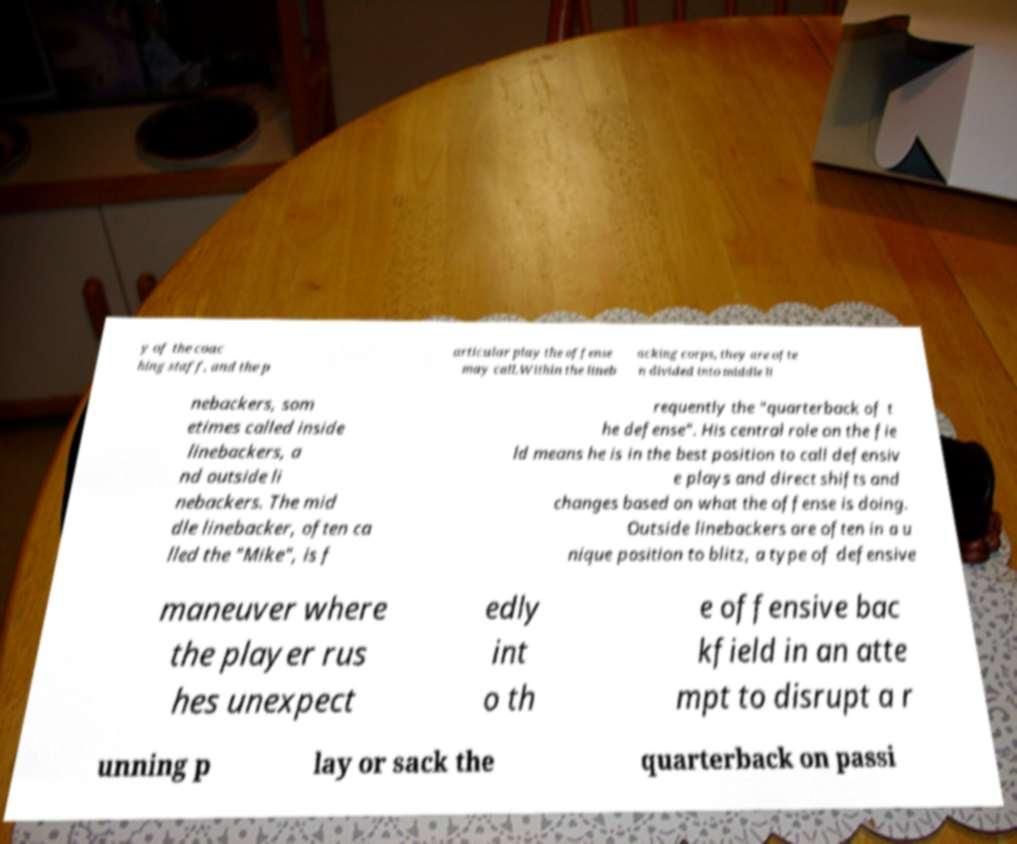There's text embedded in this image that I need extracted. Can you transcribe it verbatim? y of the coac hing staff, and the p articular play the offense may call.Within the lineb acking corps, they are ofte n divided into middle li nebackers, som etimes called inside linebackers, a nd outside li nebackers. The mid dle linebacker, often ca lled the "Mike", is f requently the "quarterback of t he defense". His central role on the fie ld means he is in the best position to call defensiv e plays and direct shifts and changes based on what the offense is doing. Outside linebackers are often in a u nique position to blitz, a type of defensive maneuver where the player rus hes unexpect edly int o th e offensive bac kfield in an atte mpt to disrupt a r unning p lay or sack the quarterback on passi 